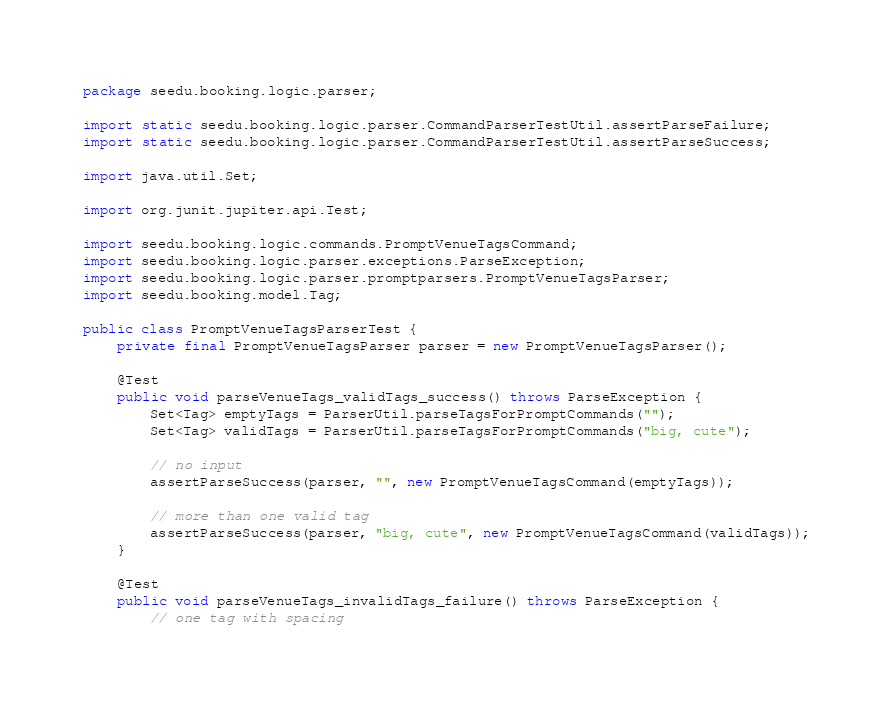<code> <loc_0><loc_0><loc_500><loc_500><_Java_>package seedu.booking.logic.parser;

import static seedu.booking.logic.parser.CommandParserTestUtil.assertParseFailure;
import static seedu.booking.logic.parser.CommandParserTestUtil.assertParseSuccess;

import java.util.Set;

import org.junit.jupiter.api.Test;

import seedu.booking.logic.commands.PromptVenueTagsCommand;
import seedu.booking.logic.parser.exceptions.ParseException;
import seedu.booking.logic.parser.promptparsers.PromptVenueTagsParser;
import seedu.booking.model.Tag;

public class PromptVenueTagsParserTest {
    private final PromptVenueTagsParser parser = new PromptVenueTagsParser();

    @Test
    public void parseVenueTags_validTags_success() throws ParseException {
        Set<Tag> emptyTags = ParserUtil.parseTagsForPromptCommands("");
        Set<Tag> validTags = ParserUtil.parseTagsForPromptCommands("big, cute");

        // no input
        assertParseSuccess(parser, "", new PromptVenueTagsCommand(emptyTags));

        // more than one valid tag
        assertParseSuccess(parser, "big, cute", new PromptVenueTagsCommand(validTags));
    }

    @Test
    public void parseVenueTags_invalidTags_failure() throws ParseException {
        // one tag with spacing</code> 